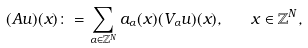Convert formula to latex. <formula><loc_0><loc_0><loc_500><loc_500>( A u ) ( x ) \colon = \sum _ { \alpha \in \mathbb { Z } ^ { N } } a _ { \alpha } ( x ) ( V _ { \alpha } u ) ( x ) , \quad x \in \mathbb { Z } ^ { N } ,</formula> 